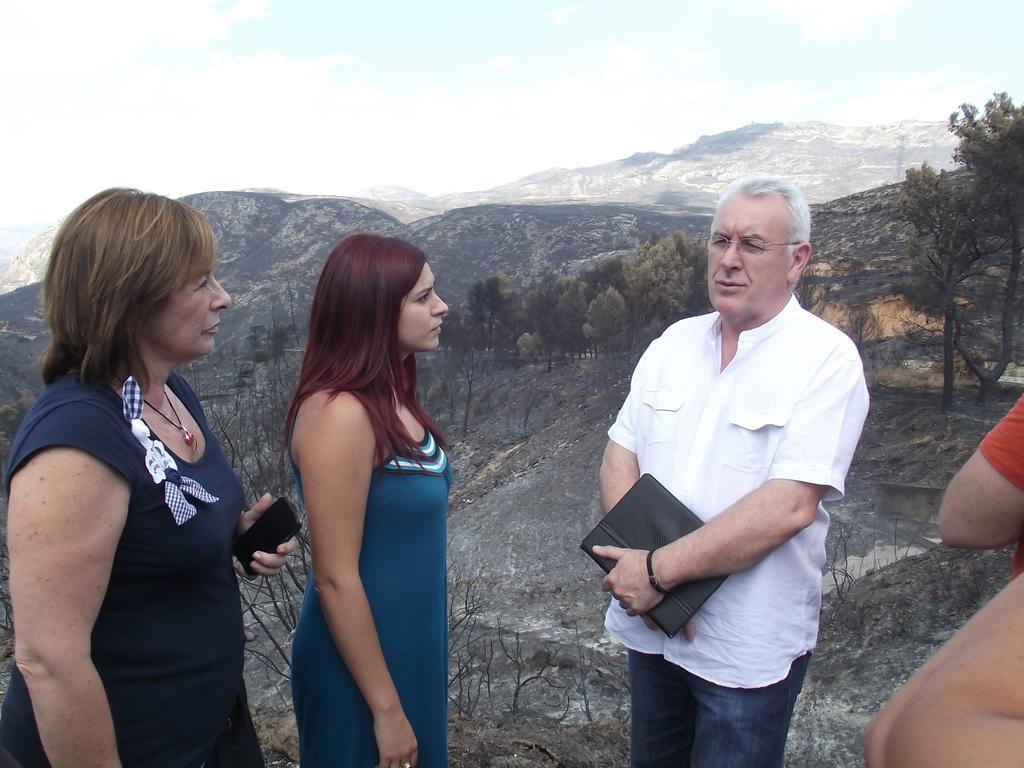Can you describe this image briefly? In this image I see a man who is wearing white shirt and blue jeans and is holding a black thing in his hand and I see that there are 2 women who are wearing blue dress and I see that this woman is holding a phone in her hand and I see 2 persons over here. In the background I see the rocks, trees, mountains and the sky. 